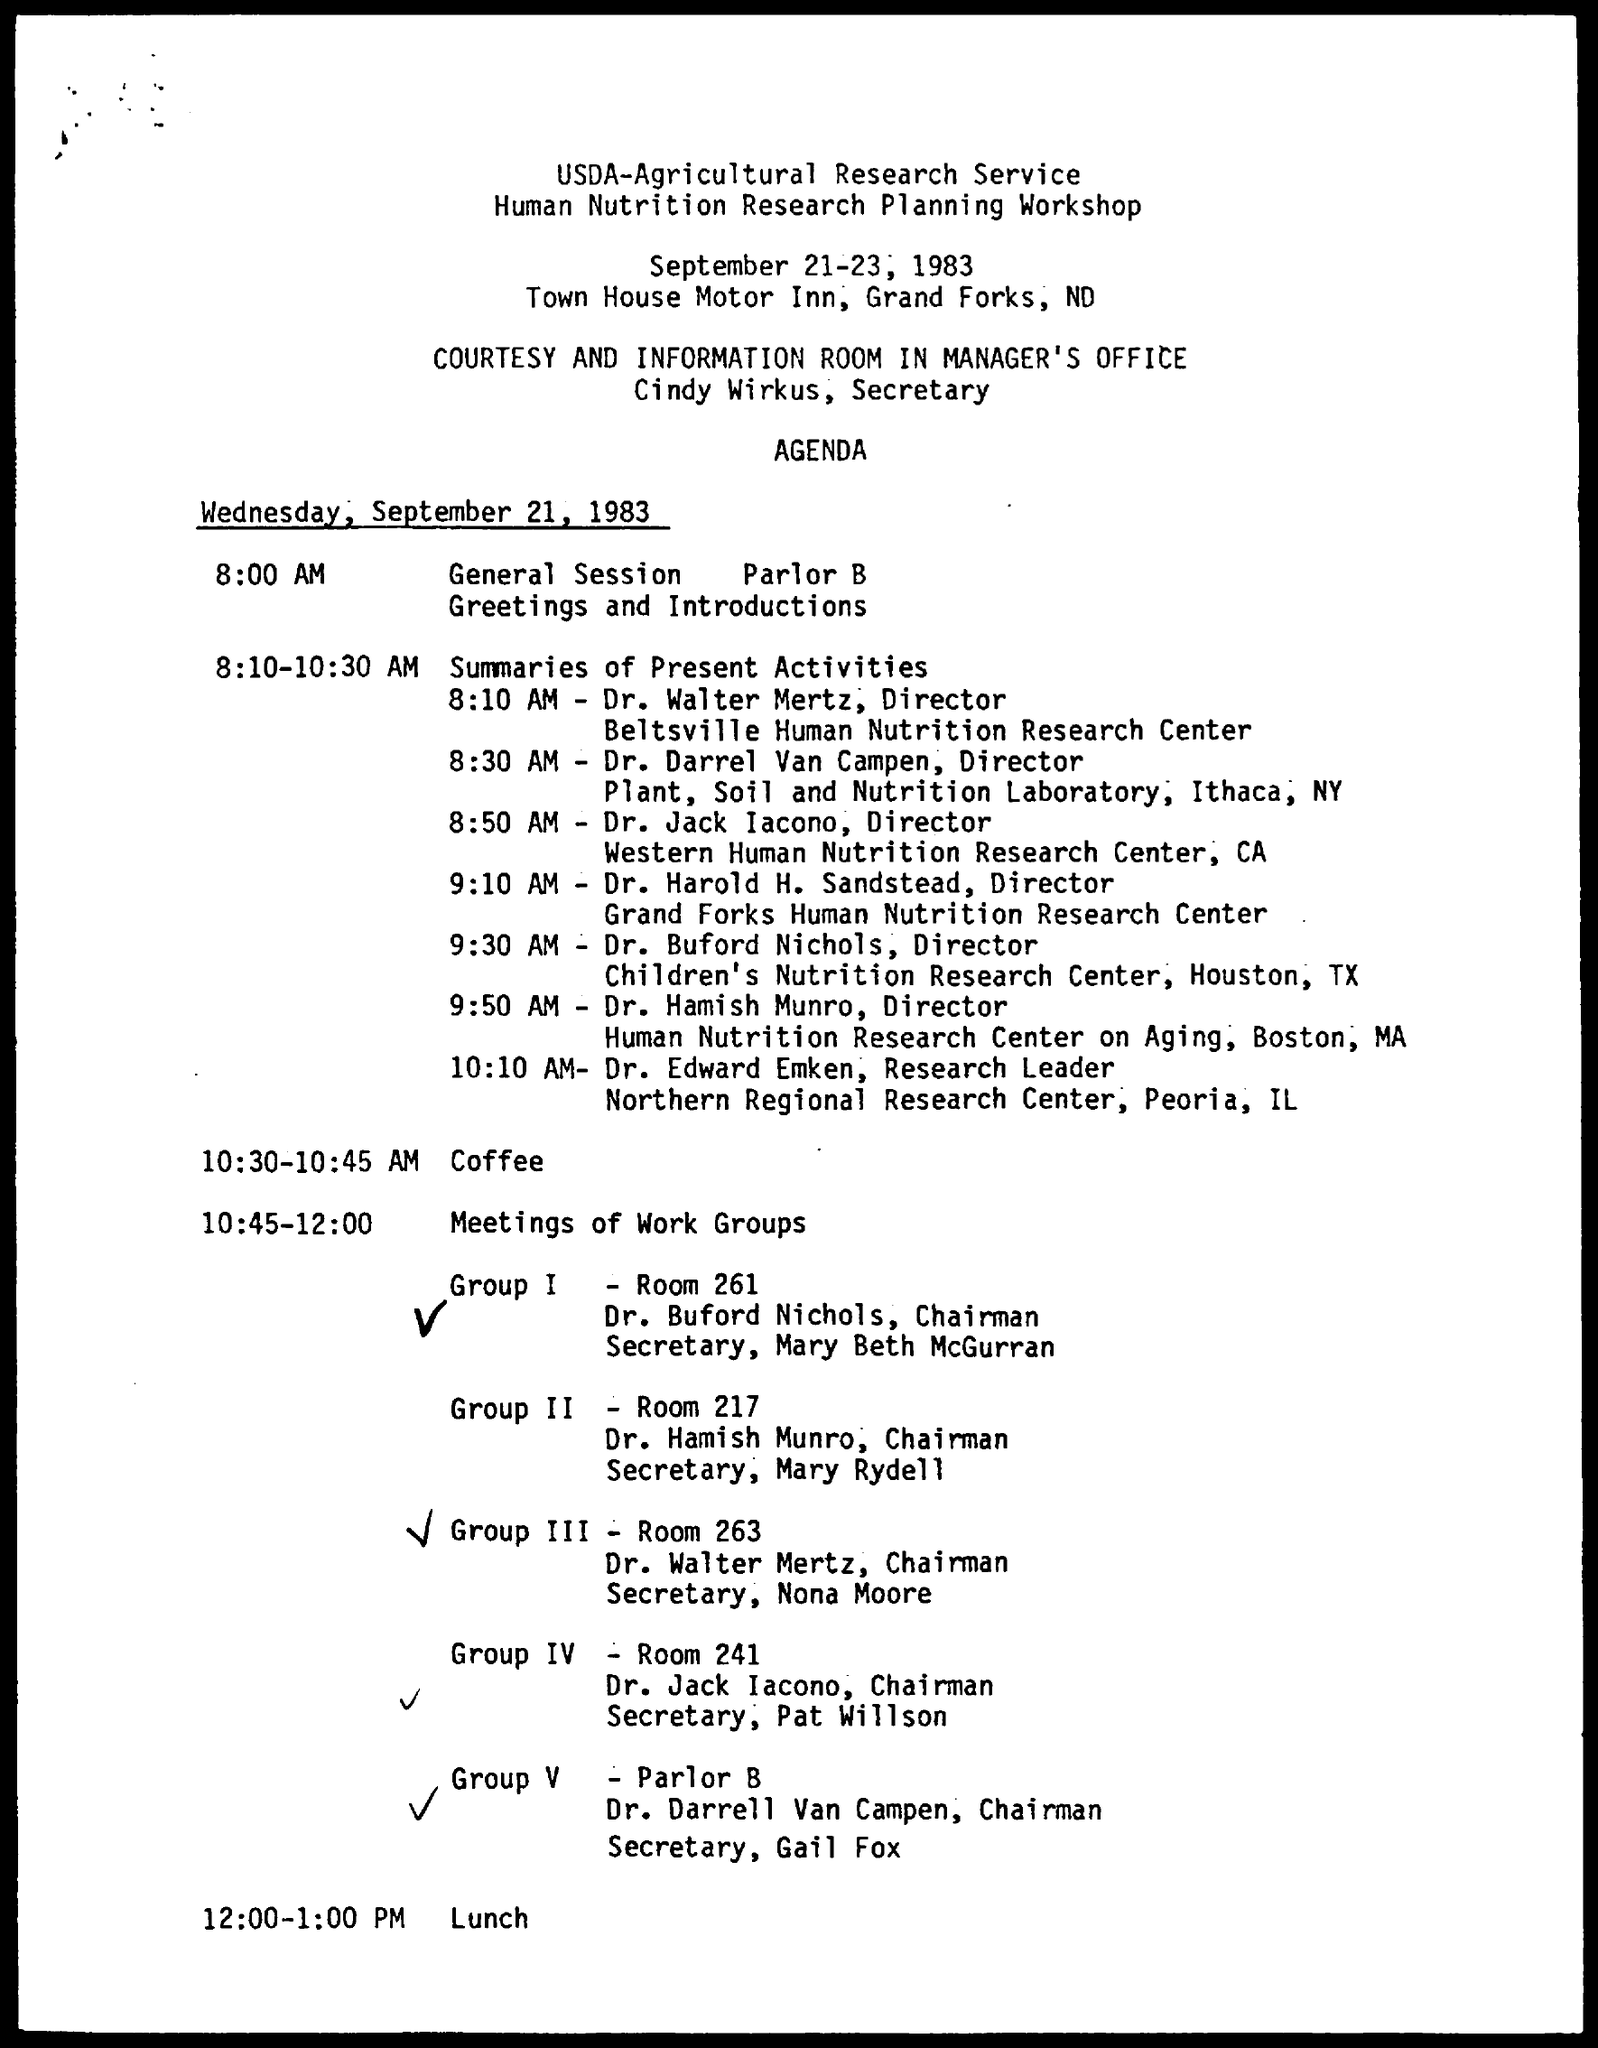Outline some significant characteristics in this image. At 2:00-1:00 PM, as specified in the agenda, lunch will be held. Dr. Walter Mertz's designation is Director. Dr. Edward Emken holds the designation of Research Leader. Dr. Darrel Van Campen's designation is "director". The schedule from 10:30-10:45 AM mentioned in the agenda is for coffee. 